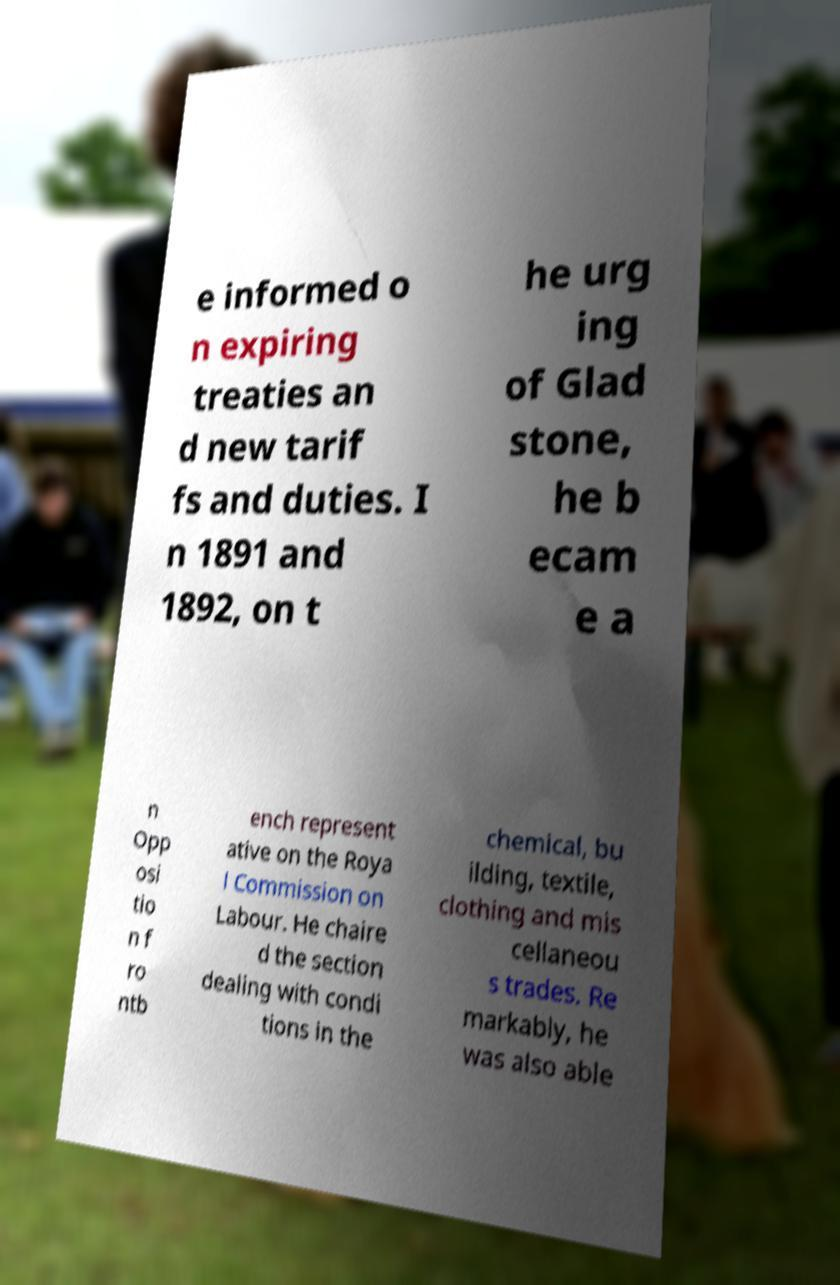I need the written content from this picture converted into text. Can you do that? e informed o n expiring treaties an d new tarif fs and duties. I n 1891 and 1892, on t he urg ing of Glad stone, he b ecam e a n Opp osi tio n f ro ntb ench represent ative on the Roya l Commission on Labour. He chaire d the section dealing with condi tions in the chemical, bu ilding, textile, clothing and mis cellaneou s trades. Re markably, he was also able 